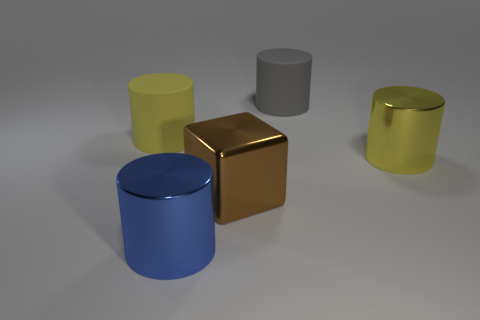Are there more large yellow matte cylinders than yellow cylinders?
Your answer should be very brief. No. What is the gray object made of?
Keep it short and to the point. Rubber. There is a blue thing to the left of the brown shiny thing; are there any big yellow objects that are on the right side of it?
Give a very brief answer. Yes. How many other objects are the same shape as the large yellow matte thing?
Your answer should be very brief. 3. Are there more cylinders on the left side of the blue shiny object than large yellow metal cylinders that are to the left of the gray cylinder?
Your response must be concise. Yes. There is a yellow cylinder to the right of the metallic block; is its size the same as the yellow cylinder that is to the left of the large gray object?
Provide a succinct answer. Yes. What is the shape of the big brown thing?
Your answer should be very brief. Cube. What is the color of the cube that is the same material as the blue object?
Keep it short and to the point. Brown. Are the gray cylinder and the large yellow object that is to the right of the blue thing made of the same material?
Your answer should be compact. No. The large block has what color?
Offer a terse response. Brown. 